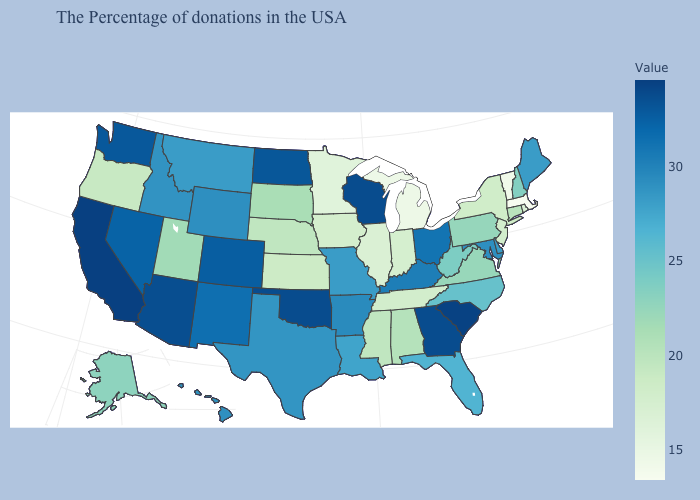Does California have the highest value in the USA?
Write a very short answer. Yes. Does Colorado have the highest value in the USA?
Concise answer only. No. Does Wisconsin have a lower value than Vermont?
Concise answer only. No. Does the map have missing data?
Write a very short answer. No. Which states hav the highest value in the Northeast?
Keep it brief. Maine. 